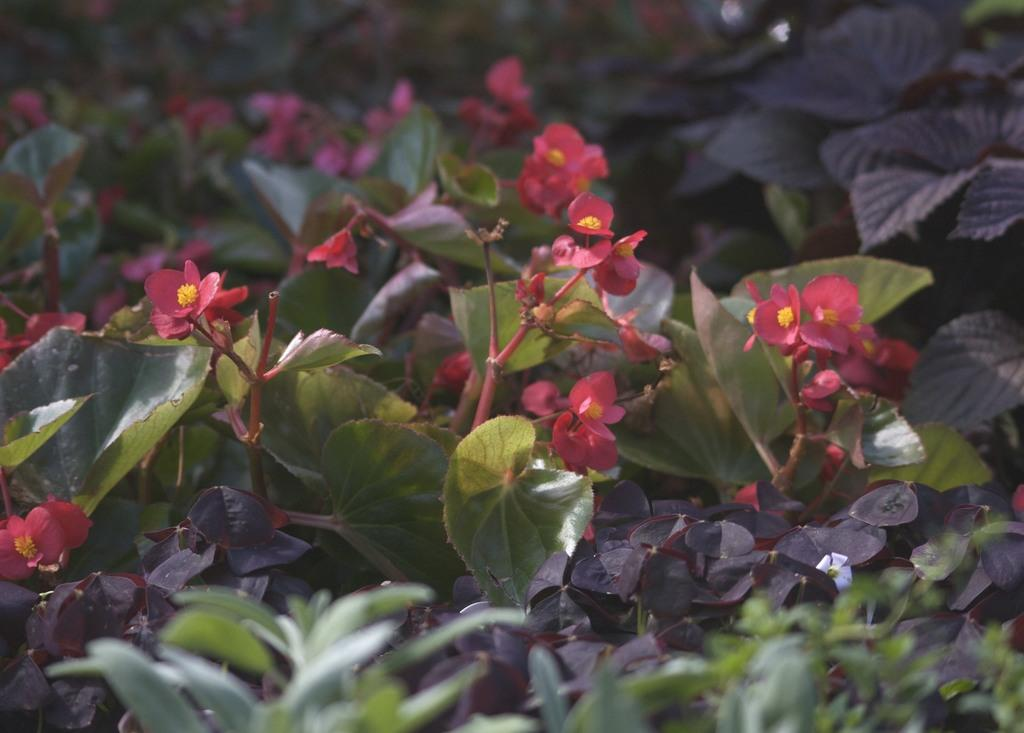What type of living organisms can be seen in the image? Plants and flowers are visible in the image. Can you describe the flowers in the image? The flowers in the image are part of the plants and add color and beauty to the scene. What type of key is used to unlock the process of digestion in the image? There is no key or reference to digestion in the image; it features plants and flowers. 